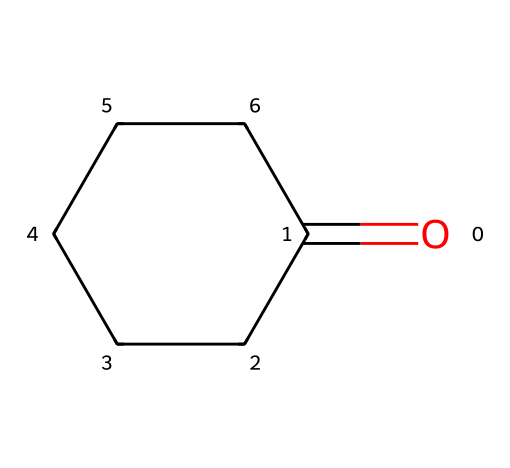What is the molecular formula of cyclohexanone? The molecular formula can be deduced from the SMILES representation. Counting the carbon atoms gives us 6 (C6), and there's one oxygen (O) from the carbonyl group indicated by "O=". Therefore, the molecular formula is C6H10O.
Answer: C6H10O How many carbon atoms are present in cyclohexanone? The SMILES representation shows six carbon atoms in the ring structure, which can be observed directly from the C's in the cyclic structure.
Answer: 6 What type of functional group is present in cyclohexanone? The carbonyl functional group (C=O) is identified in the SMILES as "O=" at the start of the structure, indicating it is a ketone.
Answer: ketone Is cyclohexanone a saturated or unsaturated compound? Although it contains a carbonyl group (C=O), the rest of the molecule is made up of a fully saturated carbon ring. Saturated compounds have only single bonds except where the double bond of the carbonyl exists.
Answer: saturated What is the total number of hydrogen atoms in cyclohexanone? From the molecular formula C6H10O, it indicates there are ten hydrogen atoms attached to the six carbon atoms.
Answer: 10 What type of chemical structure does cyclohexanone represent? Cyclohexanone falls under the category of cycloalkanes since it is a cyclic compound with a ring of carbon atoms, specifically a cycloalkyl ketone due to the presence of the carbonyl group.
Answer: cycloalkyl ketone 